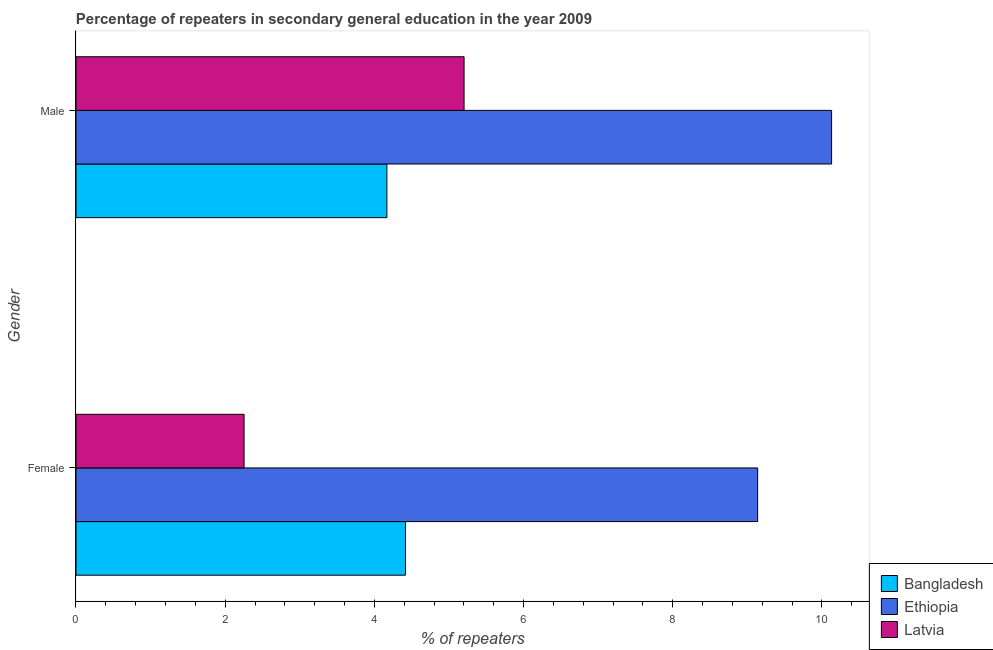How many different coloured bars are there?
Keep it short and to the point. 3. How many groups of bars are there?
Give a very brief answer. 2. Are the number of bars per tick equal to the number of legend labels?
Make the answer very short. Yes. What is the percentage of male repeaters in Bangladesh?
Ensure brevity in your answer.  4.17. Across all countries, what is the maximum percentage of female repeaters?
Your response must be concise. 9.14. Across all countries, what is the minimum percentage of female repeaters?
Your answer should be compact. 2.25. In which country was the percentage of female repeaters maximum?
Keep it short and to the point. Ethiopia. In which country was the percentage of female repeaters minimum?
Provide a short and direct response. Latvia. What is the total percentage of female repeaters in the graph?
Your answer should be very brief. 15.81. What is the difference between the percentage of female repeaters in Ethiopia and that in Latvia?
Your response must be concise. 6.88. What is the difference between the percentage of male repeaters in Bangladesh and the percentage of female repeaters in Ethiopia?
Your response must be concise. -4.97. What is the average percentage of male repeaters per country?
Offer a terse response. 6.5. What is the difference between the percentage of female repeaters and percentage of male repeaters in Ethiopia?
Your answer should be compact. -0.99. What is the ratio of the percentage of male repeaters in Ethiopia to that in Bangladesh?
Ensure brevity in your answer.  2.43. Is the percentage of male repeaters in Bangladesh less than that in Ethiopia?
Offer a terse response. Yes. In how many countries, is the percentage of female repeaters greater than the average percentage of female repeaters taken over all countries?
Provide a succinct answer. 1. What does the 3rd bar from the bottom in Female represents?
Ensure brevity in your answer.  Latvia. Are all the bars in the graph horizontal?
Give a very brief answer. Yes. How many countries are there in the graph?
Offer a terse response. 3. What is the difference between two consecutive major ticks on the X-axis?
Give a very brief answer. 2. How are the legend labels stacked?
Give a very brief answer. Vertical. What is the title of the graph?
Your answer should be very brief. Percentage of repeaters in secondary general education in the year 2009. Does "Niger" appear as one of the legend labels in the graph?
Provide a succinct answer. No. What is the label or title of the X-axis?
Keep it short and to the point. % of repeaters. What is the label or title of the Y-axis?
Ensure brevity in your answer.  Gender. What is the % of repeaters of Bangladesh in Female?
Give a very brief answer. 4.42. What is the % of repeaters of Ethiopia in Female?
Offer a terse response. 9.14. What is the % of repeaters of Latvia in Female?
Offer a very short reply. 2.25. What is the % of repeaters in Bangladesh in Male?
Offer a very short reply. 4.17. What is the % of repeaters of Ethiopia in Male?
Your answer should be compact. 10.13. What is the % of repeaters in Latvia in Male?
Keep it short and to the point. 5.2. Across all Gender, what is the maximum % of repeaters of Bangladesh?
Your response must be concise. 4.42. Across all Gender, what is the maximum % of repeaters of Ethiopia?
Give a very brief answer. 10.13. Across all Gender, what is the maximum % of repeaters in Latvia?
Provide a short and direct response. 5.2. Across all Gender, what is the minimum % of repeaters of Bangladesh?
Make the answer very short. 4.17. Across all Gender, what is the minimum % of repeaters in Ethiopia?
Ensure brevity in your answer.  9.14. Across all Gender, what is the minimum % of repeaters in Latvia?
Keep it short and to the point. 2.25. What is the total % of repeaters of Bangladesh in the graph?
Make the answer very short. 8.58. What is the total % of repeaters in Ethiopia in the graph?
Ensure brevity in your answer.  19.27. What is the total % of repeaters in Latvia in the graph?
Keep it short and to the point. 7.46. What is the difference between the % of repeaters in Bangladesh in Female and that in Male?
Provide a succinct answer. 0.25. What is the difference between the % of repeaters of Ethiopia in Female and that in Male?
Offer a very short reply. -0.99. What is the difference between the % of repeaters in Latvia in Female and that in Male?
Give a very brief answer. -2.95. What is the difference between the % of repeaters of Bangladesh in Female and the % of repeaters of Ethiopia in Male?
Your answer should be very brief. -5.71. What is the difference between the % of repeaters of Bangladesh in Female and the % of repeaters of Latvia in Male?
Keep it short and to the point. -0.79. What is the difference between the % of repeaters of Ethiopia in Female and the % of repeaters of Latvia in Male?
Make the answer very short. 3.94. What is the average % of repeaters of Bangladesh per Gender?
Keep it short and to the point. 4.29. What is the average % of repeaters in Ethiopia per Gender?
Your answer should be compact. 9.63. What is the average % of repeaters of Latvia per Gender?
Ensure brevity in your answer.  3.73. What is the difference between the % of repeaters of Bangladesh and % of repeaters of Ethiopia in Female?
Provide a succinct answer. -4.72. What is the difference between the % of repeaters in Bangladesh and % of repeaters in Latvia in Female?
Give a very brief answer. 2.16. What is the difference between the % of repeaters in Ethiopia and % of repeaters in Latvia in Female?
Provide a succinct answer. 6.88. What is the difference between the % of repeaters of Bangladesh and % of repeaters of Ethiopia in Male?
Provide a short and direct response. -5.96. What is the difference between the % of repeaters in Bangladesh and % of repeaters in Latvia in Male?
Ensure brevity in your answer.  -1.03. What is the difference between the % of repeaters of Ethiopia and % of repeaters of Latvia in Male?
Your response must be concise. 4.93. What is the ratio of the % of repeaters in Bangladesh in Female to that in Male?
Give a very brief answer. 1.06. What is the ratio of the % of repeaters in Ethiopia in Female to that in Male?
Provide a short and direct response. 0.9. What is the ratio of the % of repeaters of Latvia in Female to that in Male?
Your answer should be very brief. 0.43. What is the difference between the highest and the second highest % of repeaters in Bangladesh?
Give a very brief answer. 0.25. What is the difference between the highest and the second highest % of repeaters of Ethiopia?
Your response must be concise. 0.99. What is the difference between the highest and the second highest % of repeaters of Latvia?
Your answer should be compact. 2.95. What is the difference between the highest and the lowest % of repeaters in Bangladesh?
Keep it short and to the point. 0.25. What is the difference between the highest and the lowest % of repeaters of Ethiopia?
Ensure brevity in your answer.  0.99. What is the difference between the highest and the lowest % of repeaters in Latvia?
Make the answer very short. 2.95. 